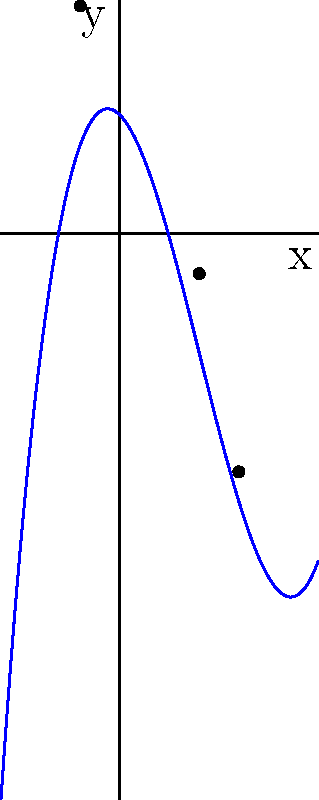As an artist and sculptor, you're exploring mathematical curves for a new sculpture series. Consider the cubic polynomial function $f(x) = 0.25x^3 - 1.5x^2 - x + 3$. Sketch the graph and identify its key features, including the y-intercept, local maximum and minimum points, and any x-intercepts. How might these features inspire your sculptural design? Let's analyze the cubic polynomial function $f(x) = 0.25x^3 - 1.5x^2 - x + 3$ step by step:

1. Y-intercept: 
   When $x = 0$, $f(0) = 3$. So the y-intercept is (0, 3).

2. First derivative:
   $f'(x) = 0.75x^2 - 3x - 1$

3. Critical points (where $f'(x) = 0$):
   $0.75x^2 - 3x - 1 = 0$
   Using the quadratic formula, we get $x ≈ -1$ and $x ≈ 4$

4. Second derivative:
   $f''(x) = 1.5x - 3$

5. Nature of critical points:
   At $x = -1$: $f''(-1) = -4.5 < 0$, so it's a local maximum
   At $x = 4$: $f''(4) = 3 > 0$, so it's a local minimum

6. Coordinates of local extrema:
   Local maximum: $(-1, f(-1)) ≈ (-1, 5.75)$
   Local minimum: $(4, f(4)) ≈ (4, -9)$

7. X-intercepts:
   Solving $0.25x^3 - 1.5x^2 - x + 3 = 0$ numerically, we get:
   $x ≈ -1.77$, $x ≈ 2$, and $x ≈ 3.77$

The curve starts below the x-axis, rises to a local maximum, then falls to a local minimum before rising again. This S-shaped curve could inspire a flowing, organic sculpture with varying thickness and curvature.
Answer: Y-intercept: (0, 3); Local maximum: (-1, 5.75); Local minimum: (4, -9); X-intercepts: -1.77, 2, and 3.77 